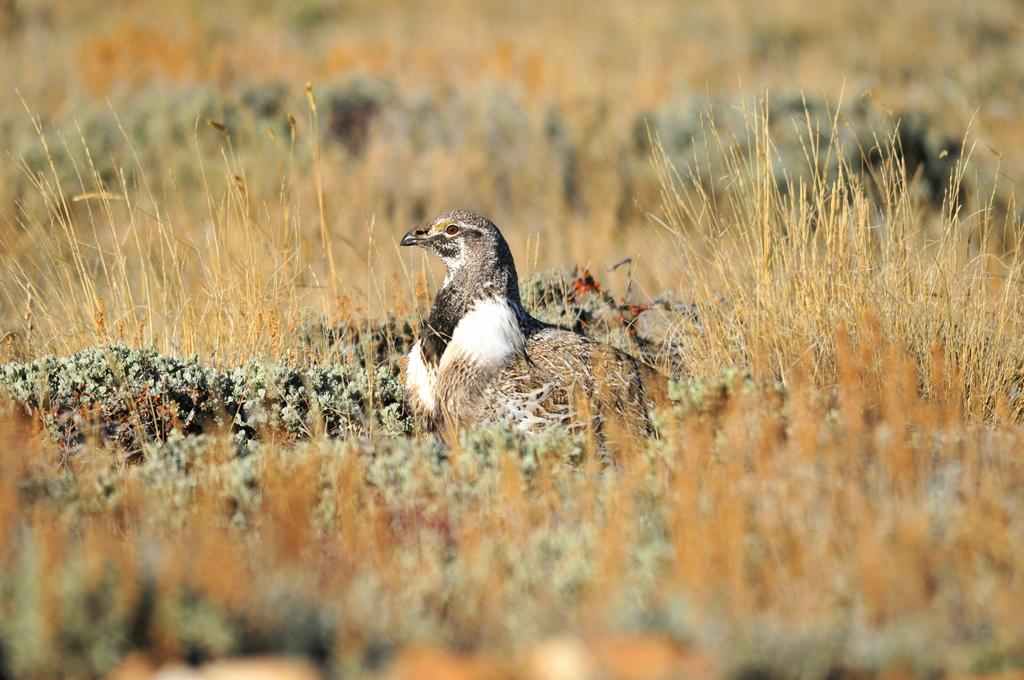What type of animal is in the image? There is a bird in the image. Can you describe the bird's coloring? The bird has black, white, ash, and brown colors. What type of vegetation is visible in the image? There is grass visible in the image. How would you describe the background of the image? The background of the image is blurry. How many crates of lettuce can be seen in the image? There are no crates or lettuce present in the image. 